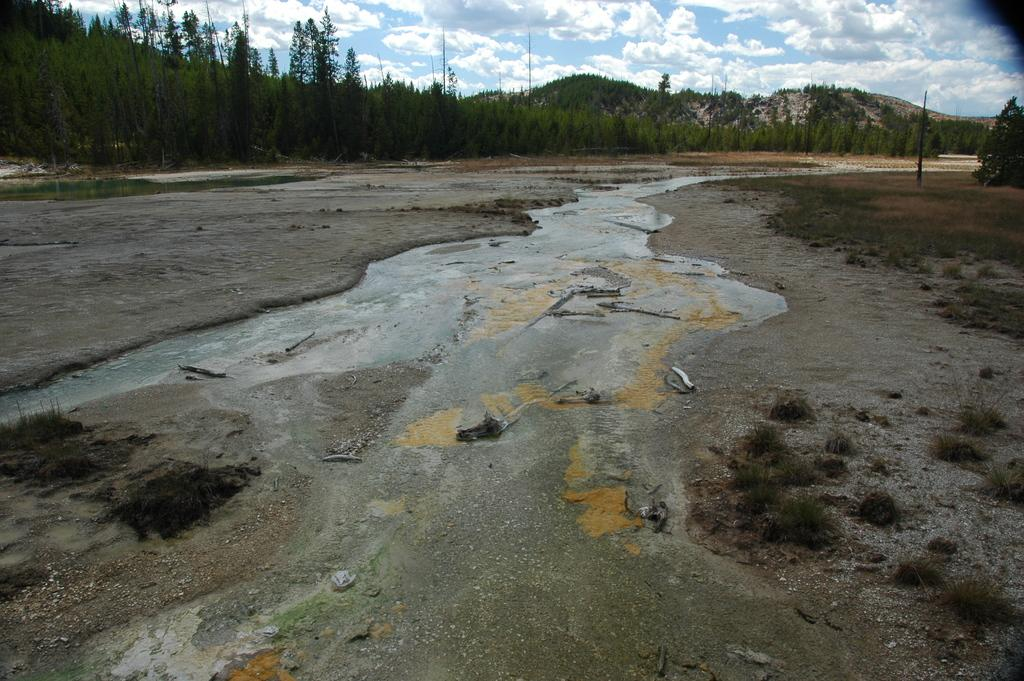What type of living organisms can be seen in the image? Plants are visible in the image. What natural element is present in the image? Water is visible in the image. What is growing in the water in the image? Algae are present in the water. What type of vegetation can be seen at the top of the image? Trees are present at the top of the image. What structure is visible at the top of the image? A pole is visible at the top of the image. What geographical feature is present at the top of the image? Hills are present at the top of the image. What is the condition of the sky at the top of the image? A cloudy sky is visible at the top of the image. How many buckets of water are being carried by the zephyr in the image? There is no zephyr or bucket present in the image. What type of finger can be seen interacting with the algae in the image? There are no fingers present in the image; only plants, water, algae, trees, a pole, hills, and a cloudy sky are visible. 